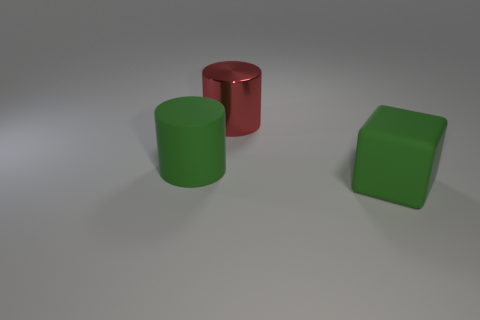What is the lighting like in this scene, and how does it affect the appearance of the objects? The lighting in the scene is moderately soft and seems to be coming from above, casting subtle shadows directly beneath the objects. This diffuse light produces soft edges on the shadows and reduces harsh reflections, enhancing the matte texture of the objects and giving the scene a calm, evenly-lit appearance. 